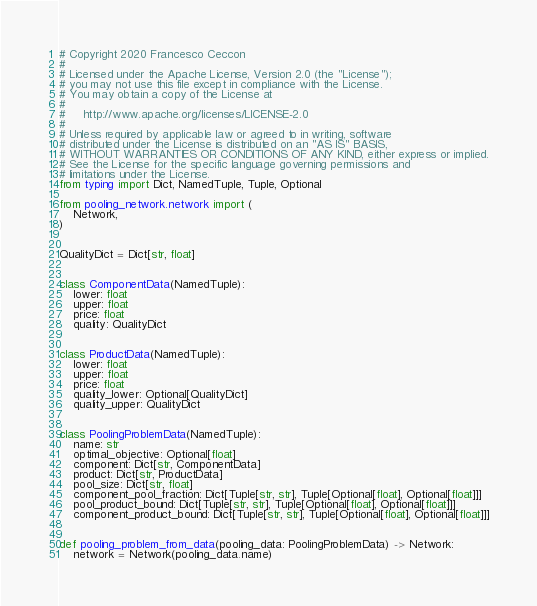Convert code to text. <code><loc_0><loc_0><loc_500><loc_500><_Python_># Copyright 2020 Francesco Ceccon
#
# Licensed under the Apache License, Version 2.0 (the "License");
# you may not use this file except in compliance with the License.
# You may obtain a copy of the License at
#
#     http://www.apache.org/licenses/LICENSE-2.0
#
# Unless required by applicable law or agreed to in writing, software
# distributed under the License is distributed on an "AS IS" BASIS,
# WITHOUT WARRANTIES OR CONDITIONS OF ANY KIND, either express or implied.
# See the License for the specific language governing permissions and
# limitations under the License.
from typing import Dict, NamedTuple, Tuple, Optional

from pooling_network.network import (
    Network,
)


QualityDict = Dict[str, float]


class ComponentData(NamedTuple):
    lower: float
    upper: float
    price: float
    quality: QualityDict


class ProductData(NamedTuple):
    lower: float
    upper: float
    price: float
    quality_lower: Optional[QualityDict]
    quality_upper: QualityDict


class PoolingProblemData(NamedTuple):
    name: str
    optimal_objective: Optional[float]
    component: Dict[str, ComponentData]
    product: Dict[str, ProductData]
    pool_size: Dict[str, float]
    component_pool_fraction: Dict[Tuple[str, str], Tuple[Optional[float], Optional[float]]]
    pool_product_bound: Dict[Tuple[str, str], Tuple[Optional[float], Optional[float]]]
    component_product_bound: Dict[Tuple[str, str], Tuple[Optional[float], Optional[float]]]


def pooling_problem_from_data(pooling_data: PoolingProblemData) -> Network:
    network = Network(pooling_data.name)
</code> 